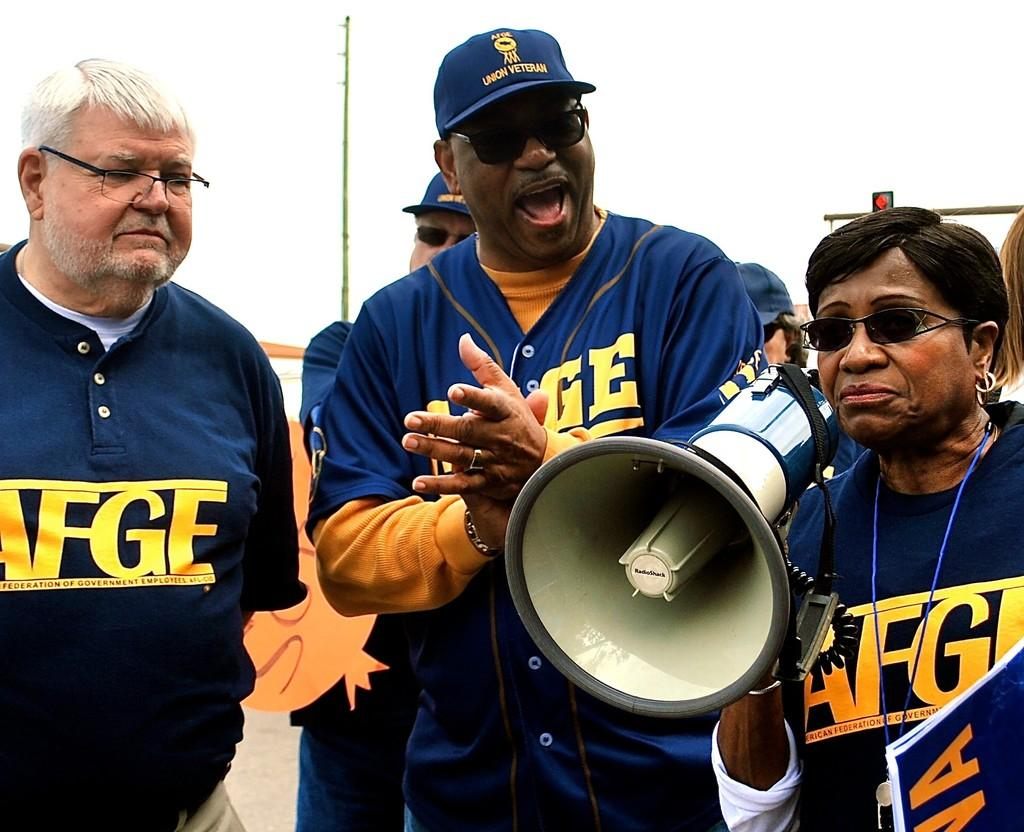<image>
Write a terse but informative summary of the picture. A woman with a loudspeaker has the letters AFGE written on her shirt 